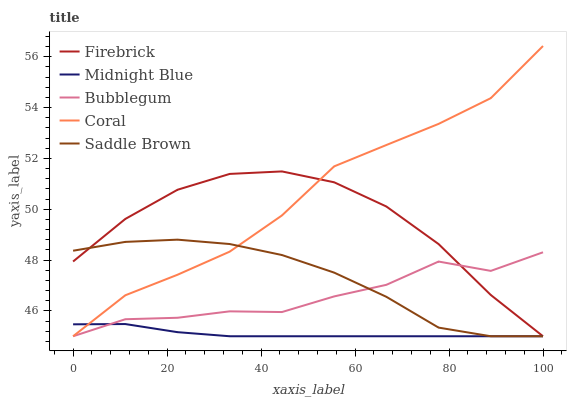Does Midnight Blue have the minimum area under the curve?
Answer yes or no. Yes. Does Coral have the maximum area under the curve?
Answer yes or no. Yes. Does Firebrick have the minimum area under the curve?
Answer yes or no. No. Does Firebrick have the maximum area under the curve?
Answer yes or no. No. Is Midnight Blue the smoothest?
Answer yes or no. Yes. Is Bubblegum the roughest?
Answer yes or no. Yes. Is Firebrick the smoothest?
Answer yes or no. No. Is Firebrick the roughest?
Answer yes or no. No. Does Coral have the lowest value?
Answer yes or no. Yes. Does Coral have the highest value?
Answer yes or no. Yes. Does Firebrick have the highest value?
Answer yes or no. No. Does Bubblegum intersect Midnight Blue?
Answer yes or no. Yes. Is Bubblegum less than Midnight Blue?
Answer yes or no. No. Is Bubblegum greater than Midnight Blue?
Answer yes or no. No. 